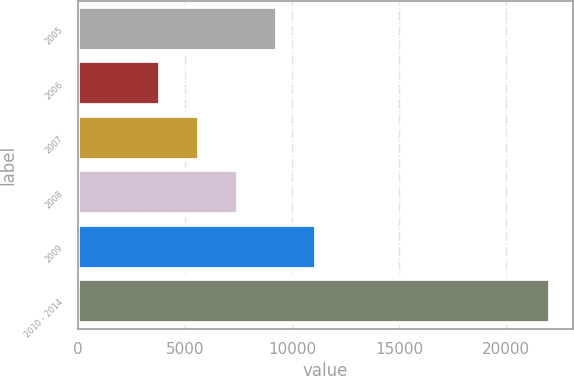<chart> <loc_0><loc_0><loc_500><loc_500><bar_chart><fcel>2005<fcel>2006<fcel>2007<fcel>2008<fcel>2009<fcel>2010 - 2014<nl><fcel>9297.6<fcel>3849<fcel>5665.2<fcel>7481.4<fcel>11113.8<fcel>22011<nl></chart> 